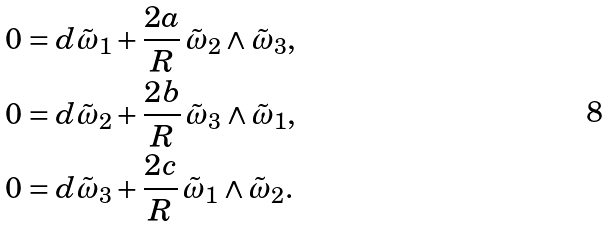Convert formula to latex. <formula><loc_0><loc_0><loc_500><loc_500>0 & = d \tilde { \omega } _ { 1 } + \frac { 2 a } { R } \, \tilde { \omega } _ { 2 } \land \tilde { \omega } _ { 3 } , \\ 0 & = d \tilde { \omega } _ { 2 } + \frac { 2 b } { R } \, \tilde { \omega } _ { 3 } \land \tilde { \omega } _ { 1 } , \\ 0 & = d \tilde { \omega } _ { 3 } + \frac { 2 c } { R } \, \tilde { \omega } _ { 1 } \land \tilde { \omega } _ { 2 } .</formula> 